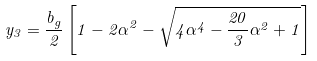<formula> <loc_0><loc_0><loc_500><loc_500>y _ { 3 } = \frac { b _ { g } } { 2 } \left [ 1 - 2 \alpha ^ { 2 } - \sqrt { 4 \alpha ^ { 4 } - \frac { 2 0 } { 3 } \alpha ^ { 2 } + 1 } \right ]</formula> 